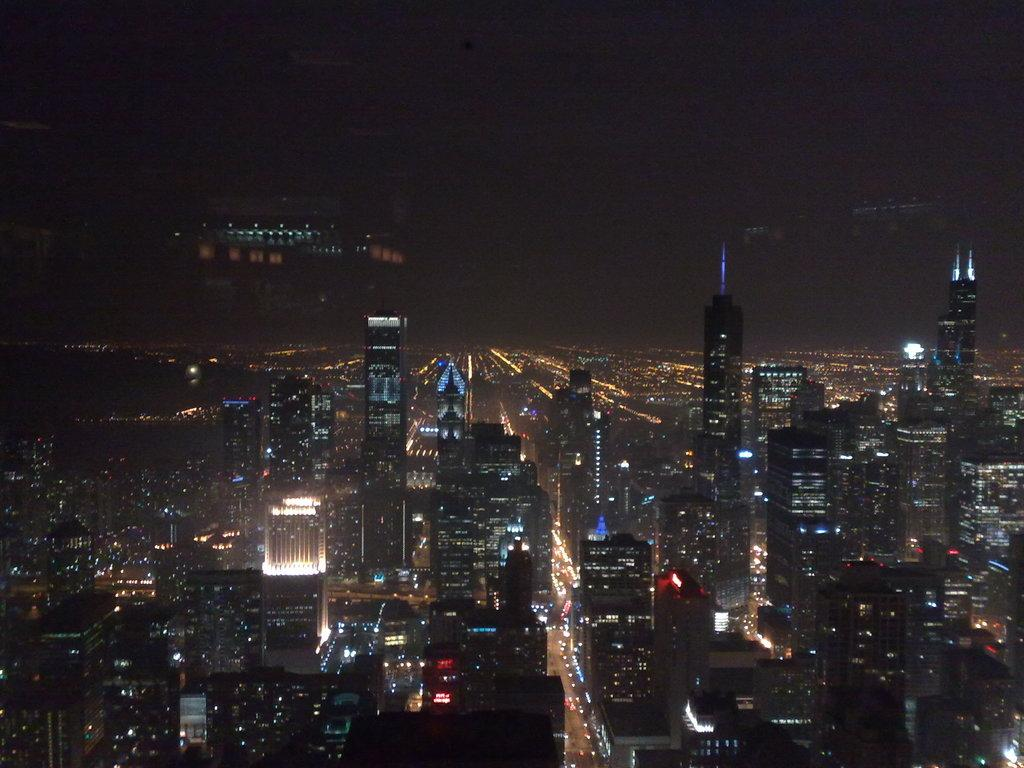What type of structures can be seen in the image? There are buildings in the image. What can be seen illuminating the buildings or surrounding areas? There are lights visible in the image. How would you describe the appearance of the sky in the image? The sky is dark in the image. What type of stone is being distributed in the image? There is no stone being distributed in the image; the focus is on the buildings, lights, and the dark sky. 